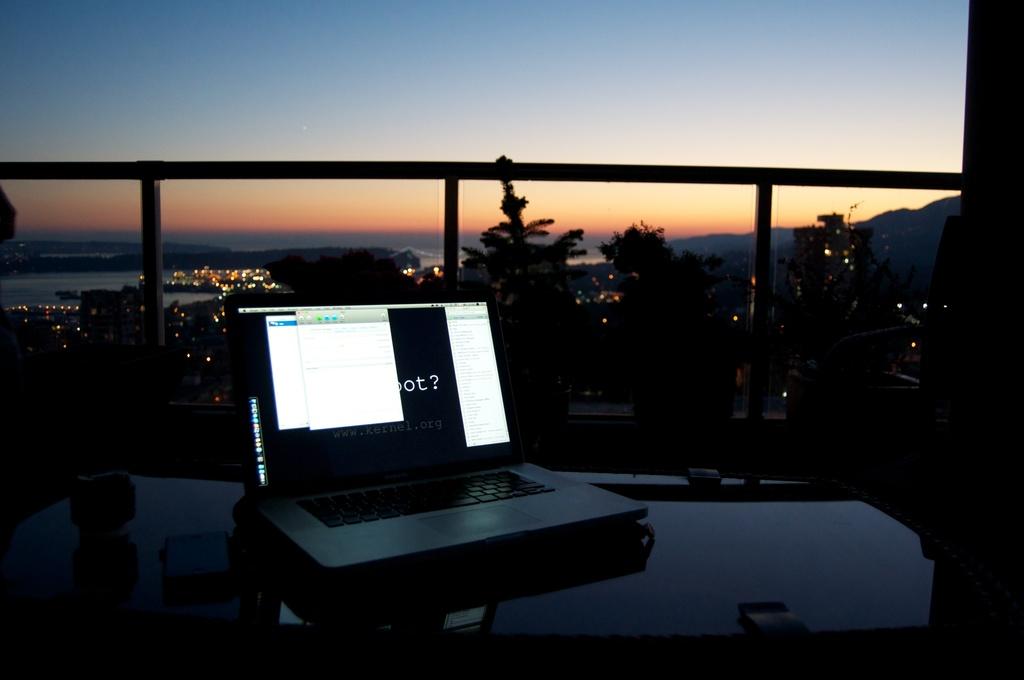What kind of mark is shown on the black part of the screen?
Offer a terse response. ?. 